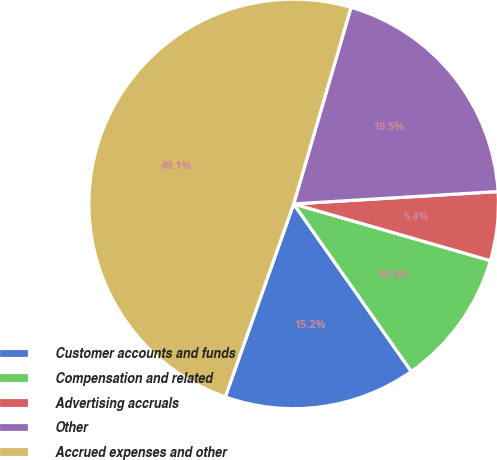Convert chart to OTSL. <chart><loc_0><loc_0><loc_500><loc_500><pie_chart><fcel>Customer accounts and funds<fcel>Compensation and related<fcel>Advertising accruals<fcel>Other<fcel>Accrued expenses and other<nl><fcel>15.16%<fcel>10.79%<fcel>5.43%<fcel>19.52%<fcel>49.1%<nl></chart> 